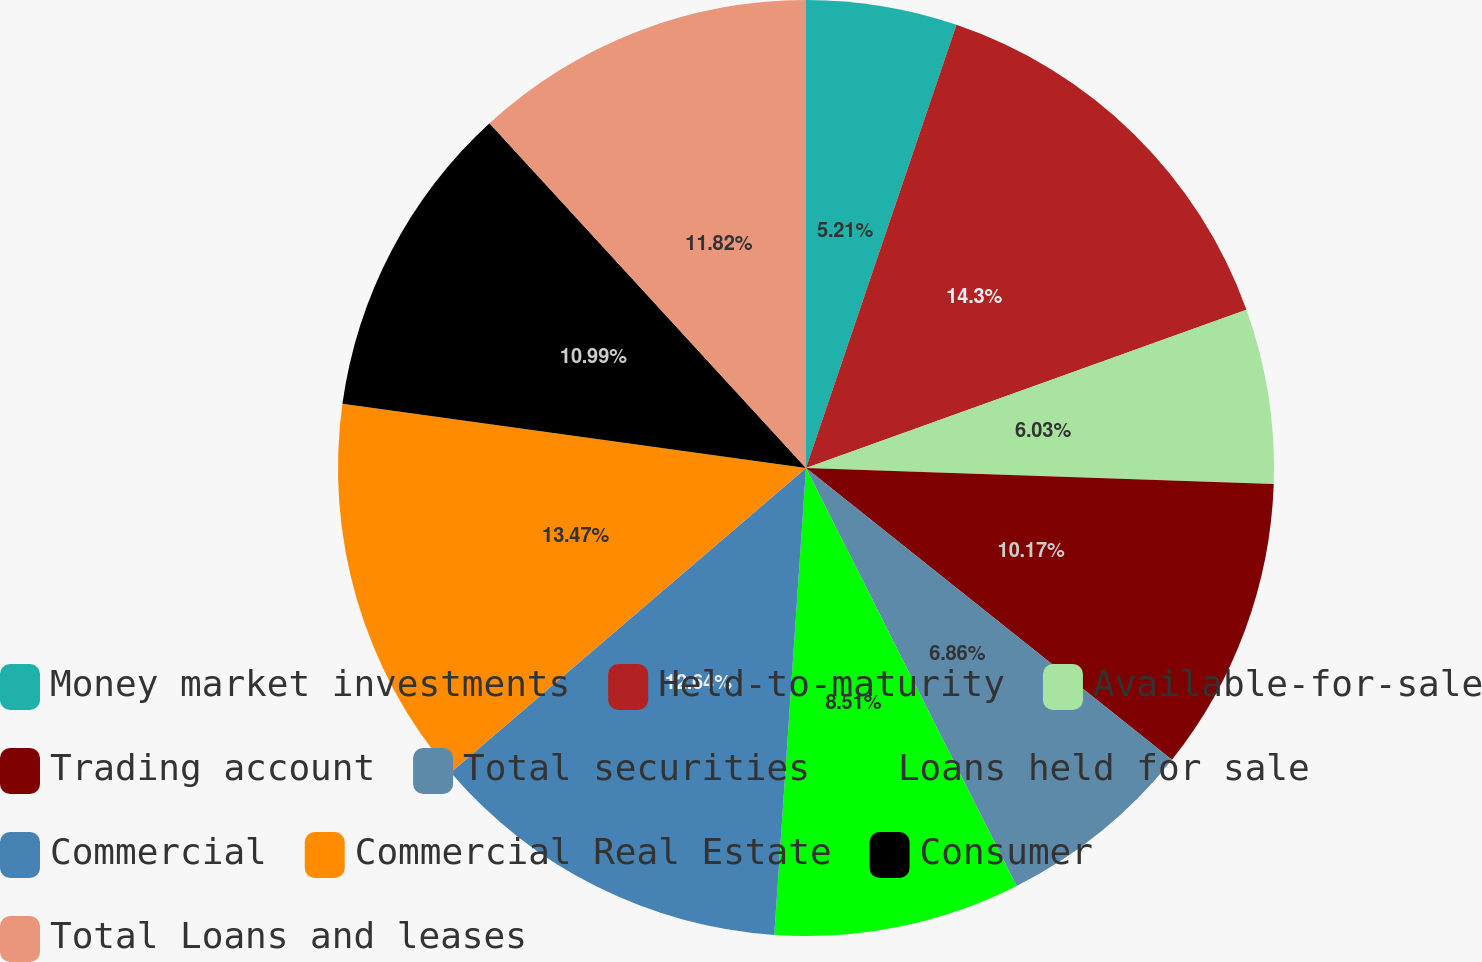<chart> <loc_0><loc_0><loc_500><loc_500><pie_chart><fcel>Money market investments<fcel>Held-to-maturity<fcel>Available-for-sale<fcel>Trading account<fcel>Total securities<fcel>Loans held for sale<fcel>Commercial<fcel>Commercial Real Estate<fcel>Consumer<fcel>Total Loans and leases<nl><fcel>5.21%<fcel>14.3%<fcel>6.03%<fcel>10.17%<fcel>6.86%<fcel>8.51%<fcel>12.64%<fcel>13.47%<fcel>10.99%<fcel>11.82%<nl></chart> 